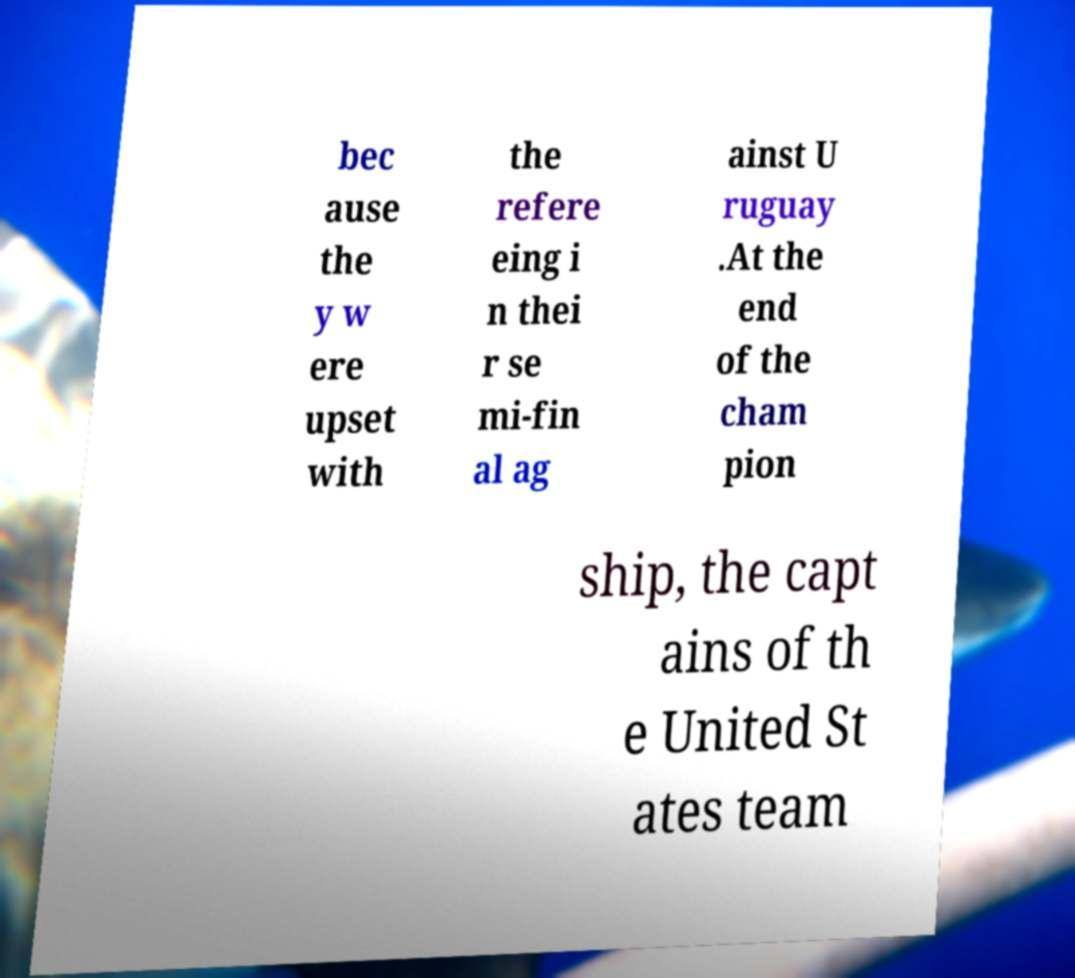There's text embedded in this image that I need extracted. Can you transcribe it verbatim? bec ause the y w ere upset with the refere eing i n thei r se mi-fin al ag ainst U ruguay .At the end of the cham pion ship, the capt ains of th e United St ates team 